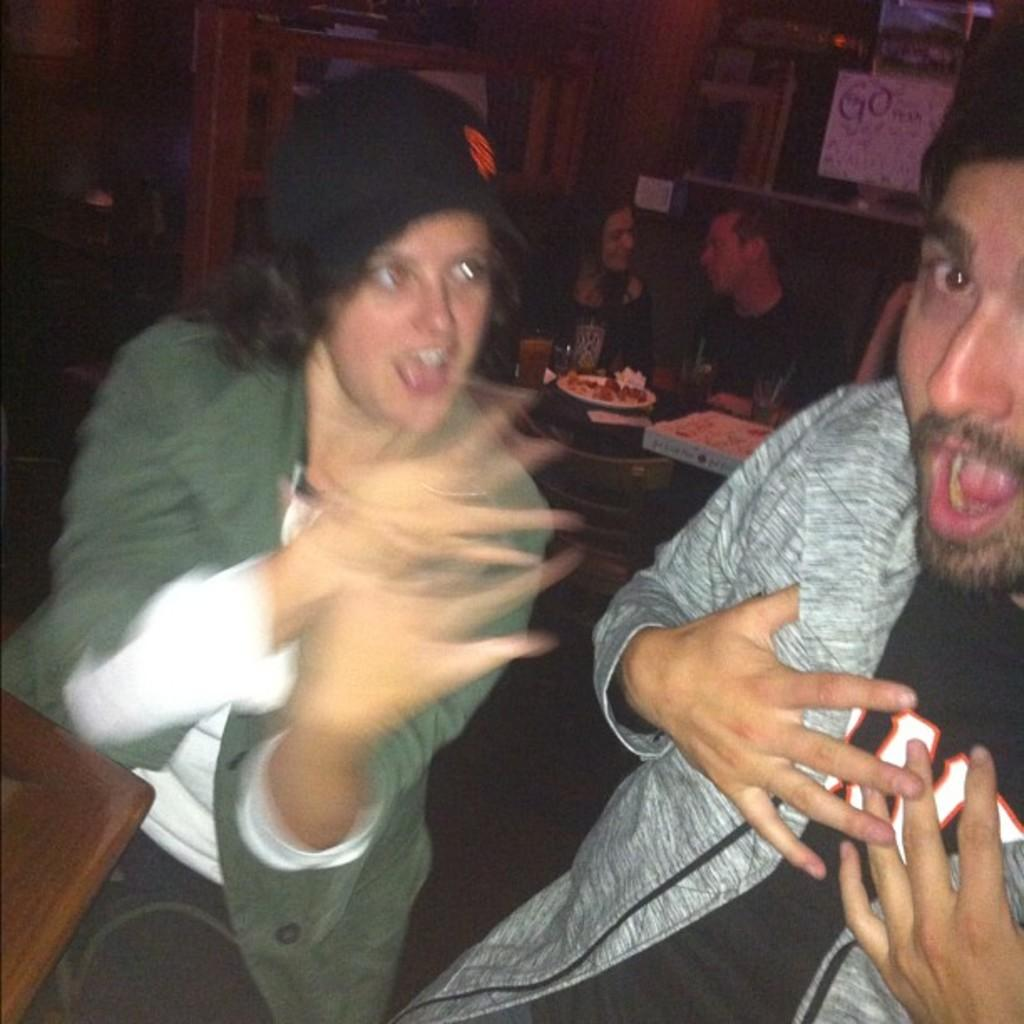What are the people in the image doing? The people in the image are sitting. What food is visible on the table in the image? There are pizzas on a table in the image. What type of furniture is present in the image? There are chairs in the image. What can be seen on the wall in the background of the image? There is a paper on the wall in the background of the image. How many zebras are present in the image? There are no zebras present in the image. What type of party is being held in the image? There is no indication of a party in the image. 